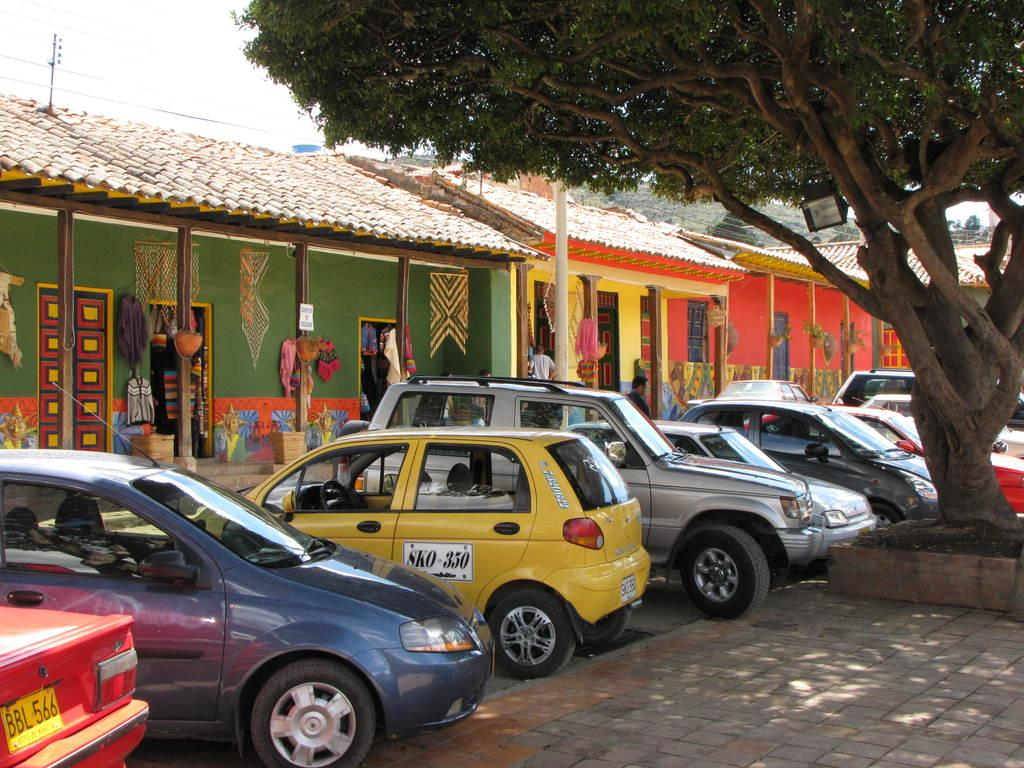<image>
Present a compact description of the photo's key features. some cars with one that says sko on it 